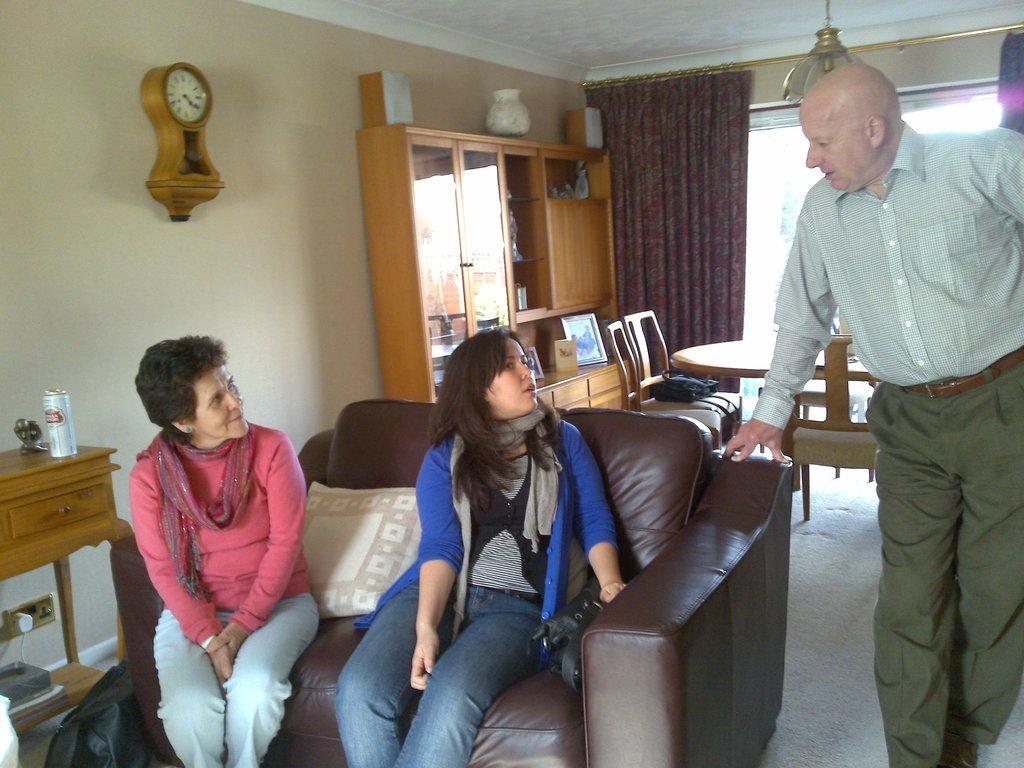How would you summarize this image in a sentence or two? As we can see in the image there is a wall, clock curtain and two people sitting on sofa and there is a man standing over here and there is a dining table. 